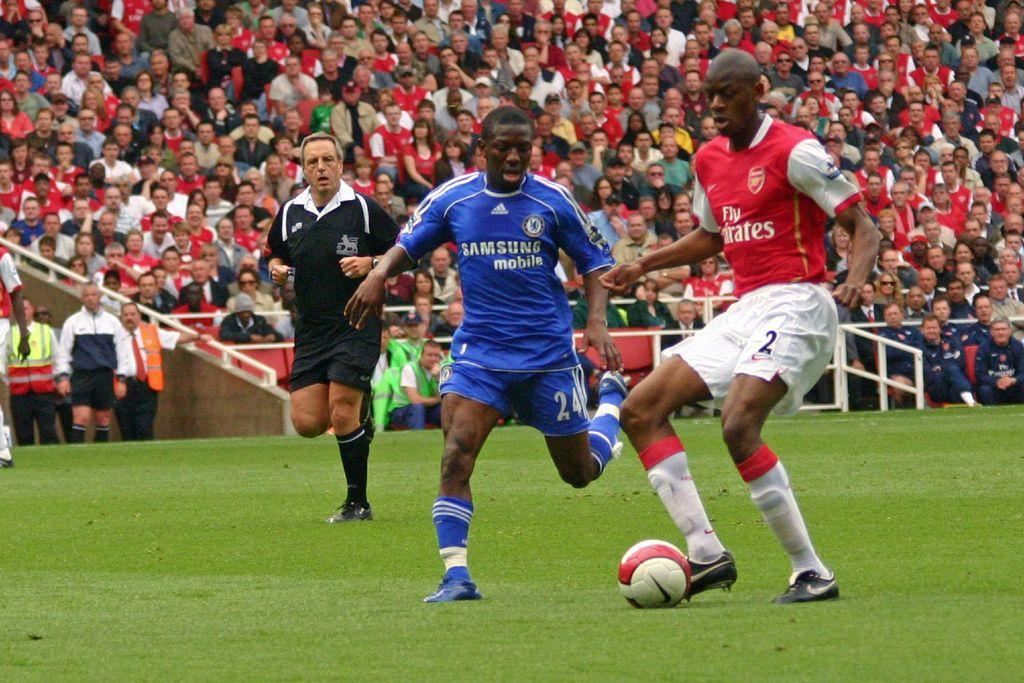<image>
Write a terse but informative summary of the picture. A man wearing a blue Samsung Mobile tshirt is playing soccer. 